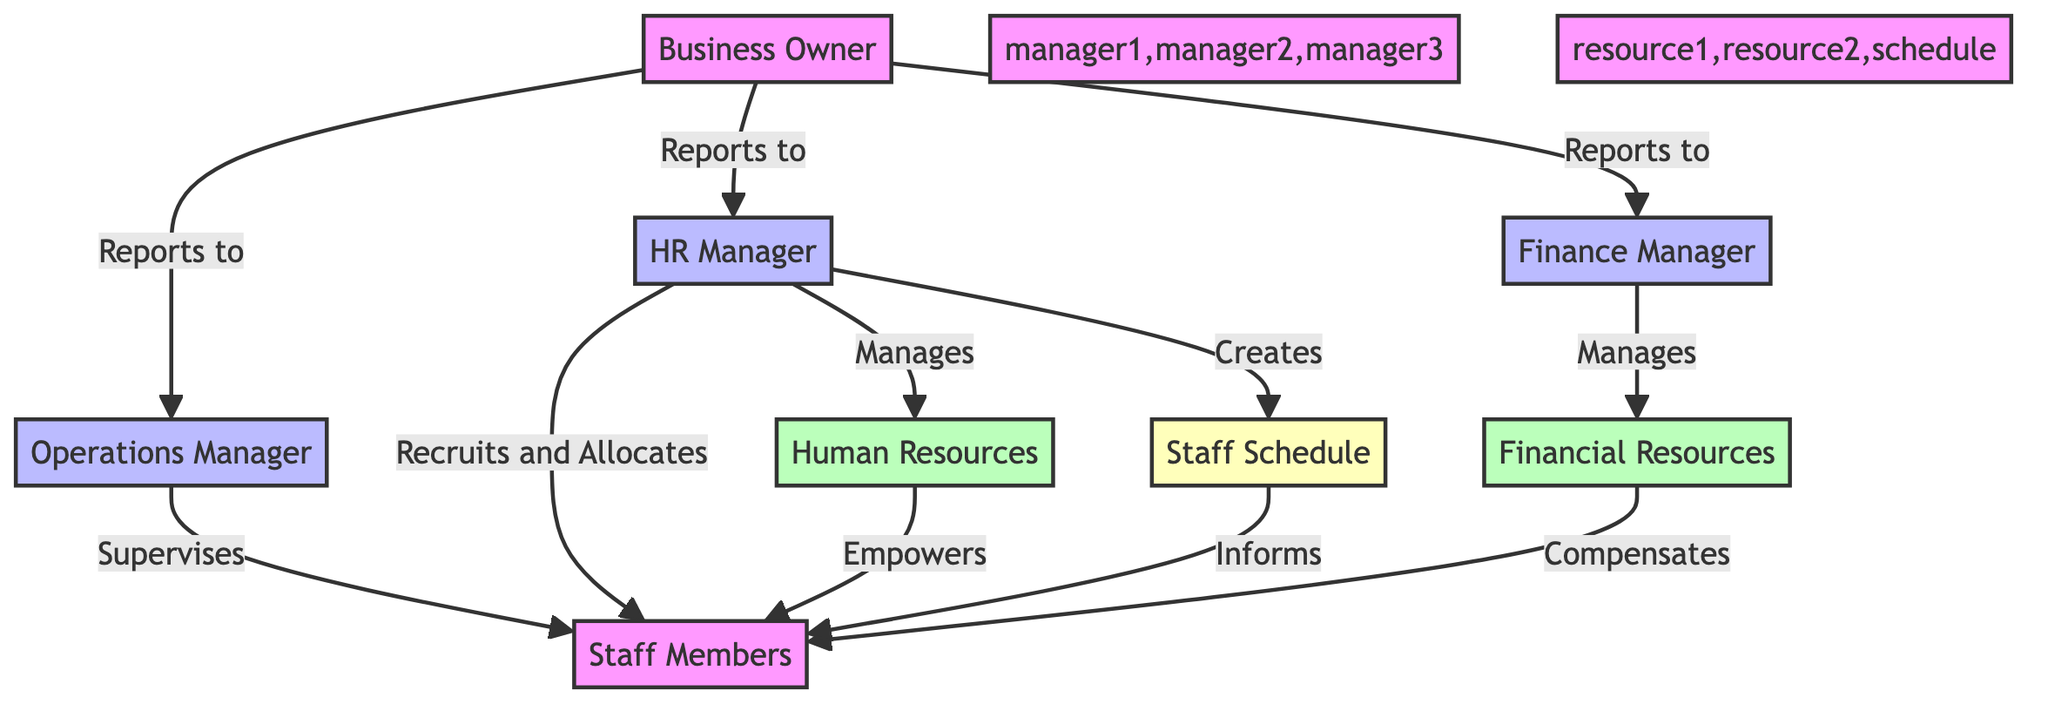What is the role of the owner in the diagram? The owner is connected to three managers, indicating that they report to each one of them. This suggests that the owner oversees overall operations and has a strategic role in the business's management.
Answer: Business Owner How many managers are in the diagram? The diagram contains three distinct managers, each represented as a separate node connected to the owner. This includes the Operations Manager, HR Manager, and Finance Manager.
Answer: 3 Which manager supervises the staff? The Operations Manager is depicted as supervising the staff members, as shown by the direct connection from manager1 (Operations Manager) to staff in the diagram.
Answer: Operations Manager What do staff members inform through the schedule? The staff members are informed through the schedule, which is the output node connected to them. This indicates that the staff rely on this schedule for their work assignments or shifts.
Answer: Staff Schedule Who manages financial resources? The Finance Manager directly manages financial resources, as indicated by the connection from manager3 (Finance Manager) to resource2 (Financial Resources) in the diagram.
Answer: Finance Manager What are the two types of resources represented in the diagram? The diagram shows two types of resources, namely Human Resources and Financial Resources, each connected to the relevant manager responsible for managing them.
Answer: Human Resources and Financial Resources How do human resources empower staff? The diagram indicates that human resources empower the staff, depicted by the arrow from resource1 (Human Resources) to staff, suggesting that the management of human resources aims to enhance staff effectiveness.
Answer: Empowers Which manager creates the staff schedule? The HR Manager creates the schedule for the staff, as indicated by the direct connection from manager2 (HR Manager) to the schedule node in the diagram.
Answer: HR Manager What is the relationship between the HR Manager and staff members? The HR Manager recruits and allocates staff members, reflecting a direct relationship aimed at effectively managing human resources according to the diagram.
Answer: Recruits and Allocates 